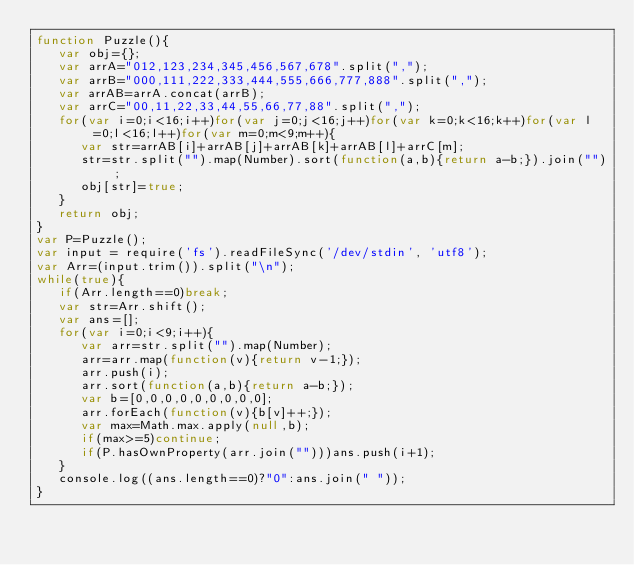Convert code to text. <code><loc_0><loc_0><loc_500><loc_500><_JavaScript_>function Puzzle(){
   var obj={};
   var arrA="012,123,234,345,456,567,678".split(",");
   var arrB="000,111,222,333,444,555,666,777,888".split(",");
   var arrAB=arrA.concat(arrB);
   var arrC="00,11,22,33,44,55,66,77,88".split(",");
   for(var i=0;i<16;i++)for(var j=0;j<16;j++)for(var k=0;k<16;k++)for(var l=0;l<16;l++)for(var m=0;m<9;m++){
      var str=arrAB[i]+arrAB[j]+arrAB[k]+arrAB[l]+arrC[m];
      str=str.split("").map(Number).sort(function(a,b){return a-b;}).join("");
      obj[str]=true;
   }
   return obj;
}
var P=Puzzle();
var input = require('fs').readFileSync('/dev/stdin', 'utf8');
var Arr=(input.trim()).split("\n");
while(true){
   if(Arr.length==0)break;
   var str=Arr.shift();
   var ans=[];
   for(var i=0;i<9;i++){
      var arr=str.split("").map(Number);
      arr=arr.map(function(v){return v-1;});
      arr.push(i);
      arr.sort(function(a,b){return a-b;});
      var b=[0,0,0,0,0,0,0,0,0];
      arr.forEach(function(v){b[v]++;});
      var max=Math.max.apply(null,b);
      if(max>=5)continue;
      if(P.hasOwnProperty(arr.join("")))ans.push(i+1);
   }
   console.log((ans.length==0)?"0":ans.join(" "));
}</code> 